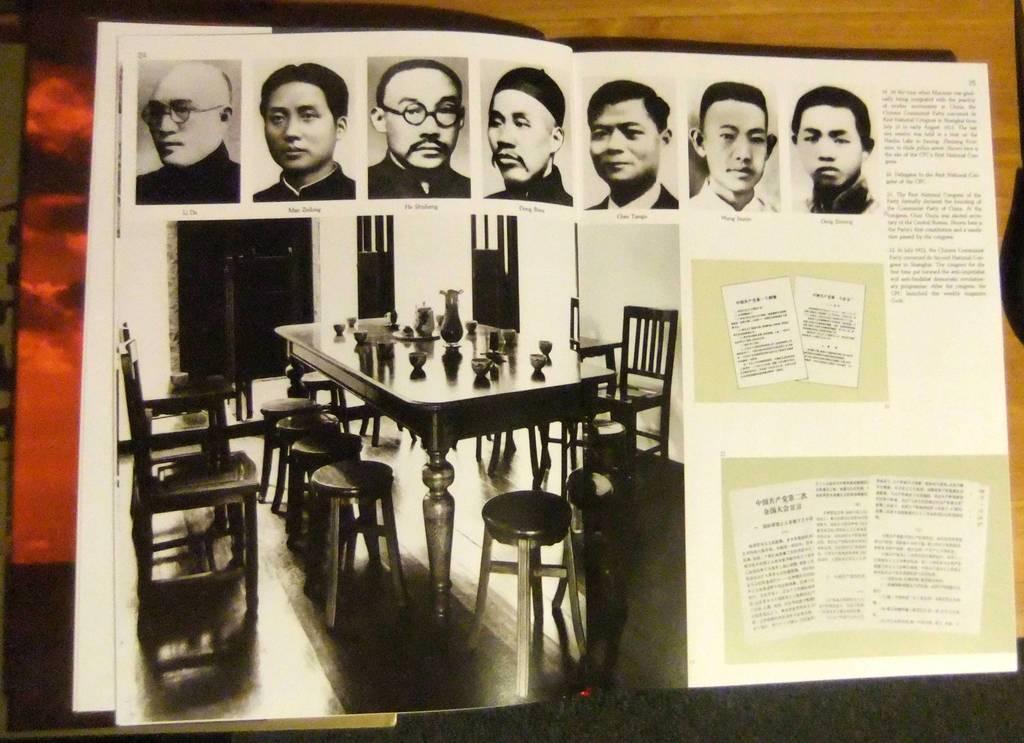Please provide a concise description of this image. In this image I can see it looks like a book, in that there are chairs and there is a dining table. At the top there are images of men, on the right side there is the text. 